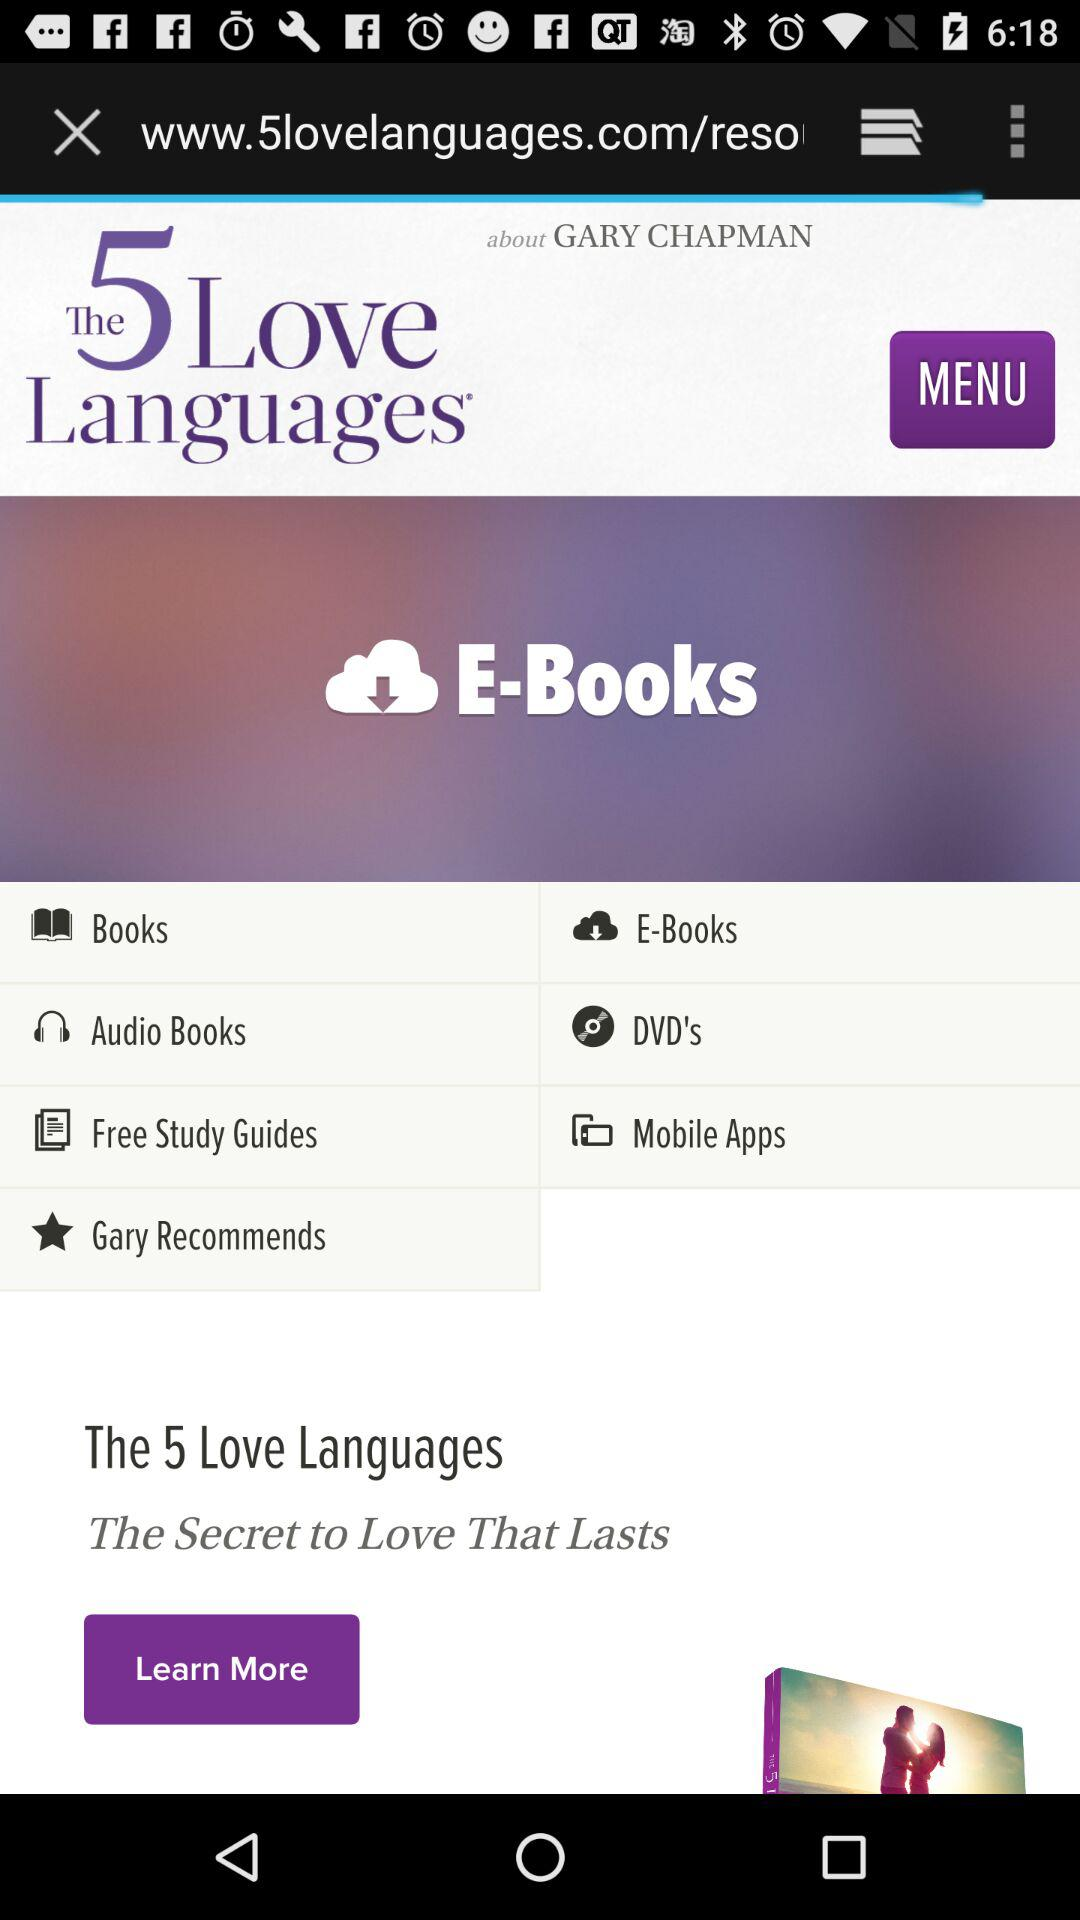Who is the author of the book? The author of the book is Gary Chapman. 